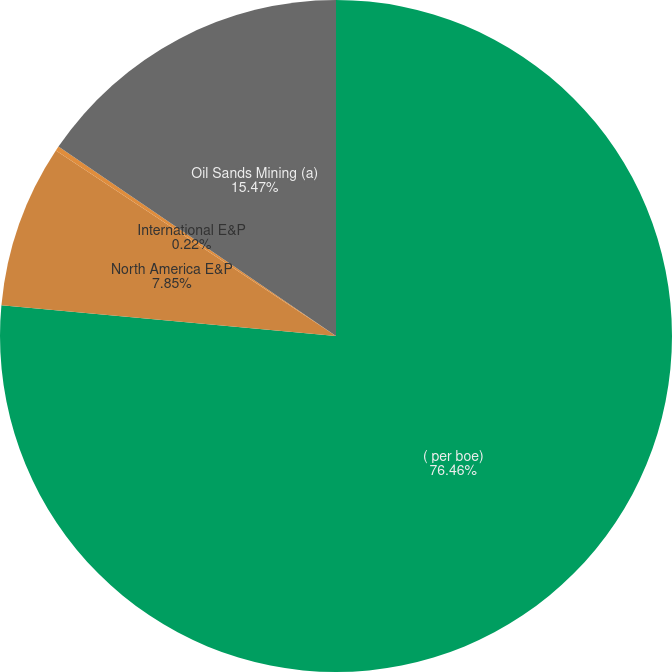Convert chart to OTSL. <chart><loc_0><loc_0><loc_500><loc_500><pie_chart><fcel>( per boe)<fcel>North America E&P<fcel>International E&P<fcel>Oil Sands Mining (a)<nl><fcel>76.46%<fcel>7.85%<fcel>0.22%<fcel>15.47%<nl></chart> 